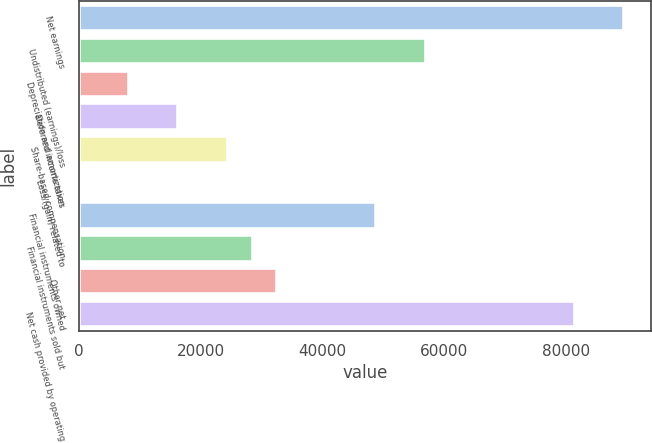<chart> <loc_0><loc_0><loc_500><loc_500><bar_chart><fcel>Net earnings<fcel>Undistributed (earnings)/loss<fcel>Depreciation and amortization<fcel>Deferred income taxes<fcel>Share-based compensation<fcel>Loss/(gain) related to<fcel>Financial instruments owned<fcel>Financial instruments sold but<fcel>Other net<fcel>Net cash provided by operating<nl><fcel>89554<fcel>56990<fcel>8144<fcel>16285<fcel>24426<fcel>3<fcel>48849<fcel>28496.5<fcel>32567<fcel>81413<nl></chart> 